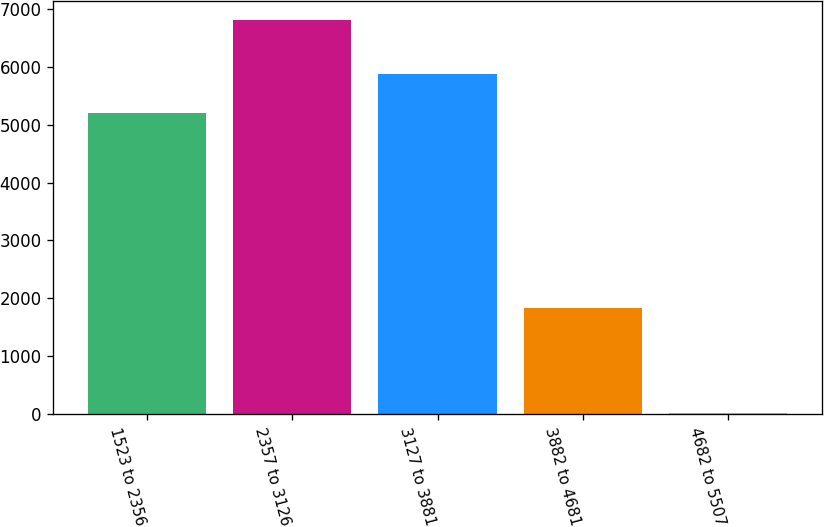Convert chart. <chart><loc_0><loc_0><loc_500><loc_500><bar_chart><fcel>1523 to 2356<fcel>2357 to 3126<fcel>3127 to 3881<fcel>3882 to 4681<fcel>4682 to 5507<nl><fcel>5194<fcel>6804<fcel>5872.1<fcel>1824<fcel>23<nl></chart> 